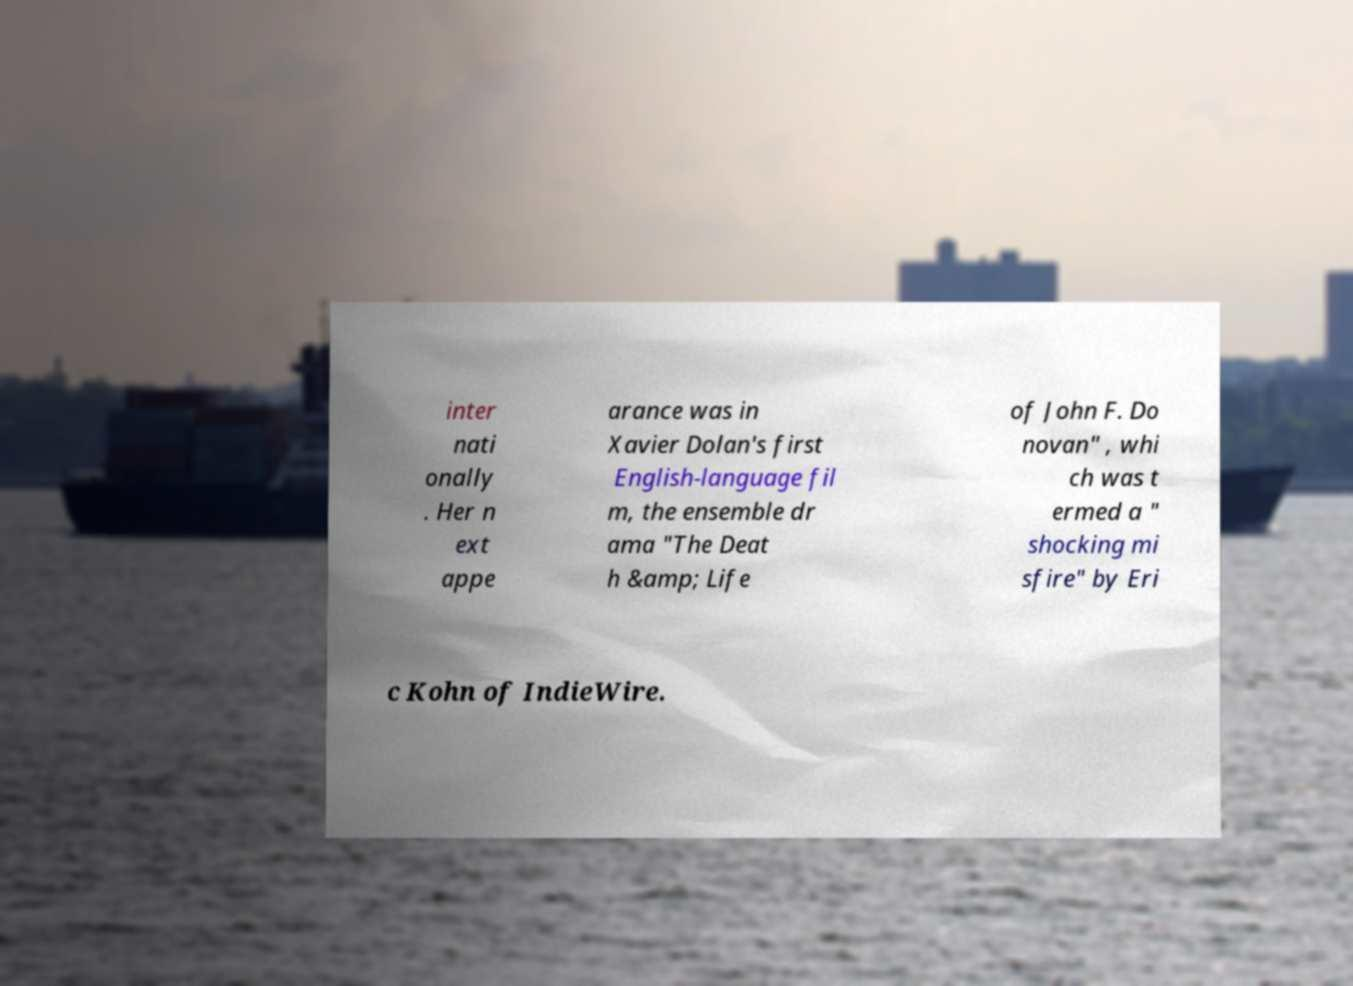I need the written content from this picture converted into text. Can you do that? inter nati onally . Her n ext appe arance was in Xavier Dolan's first English-language fil m, the ensemble dr ama "The Deat h &amp; Life of John F. Do novan" , whi ch was t ermed a " shocking mi sfire" by Eri c Kohn of IndieWire. 